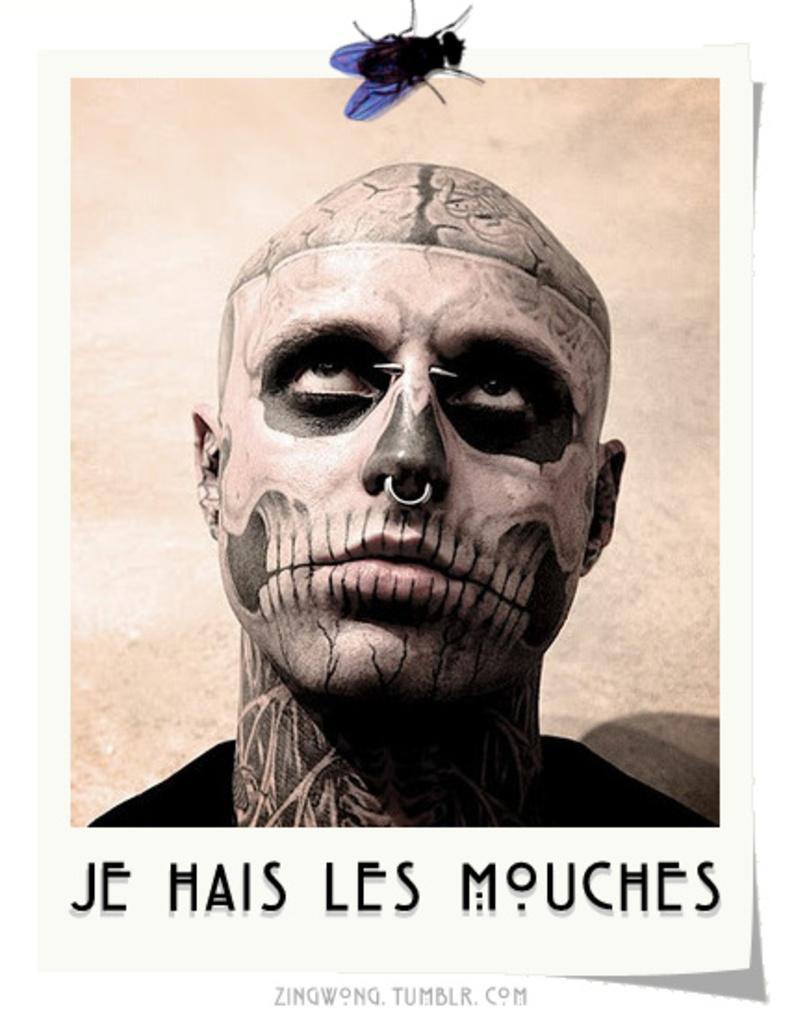Describe this image in one or two sentences. It is an edited image there is a poster and in the poster there is a picture of a person, under the picture there is some text and there is a picture of a fly above the poster. 